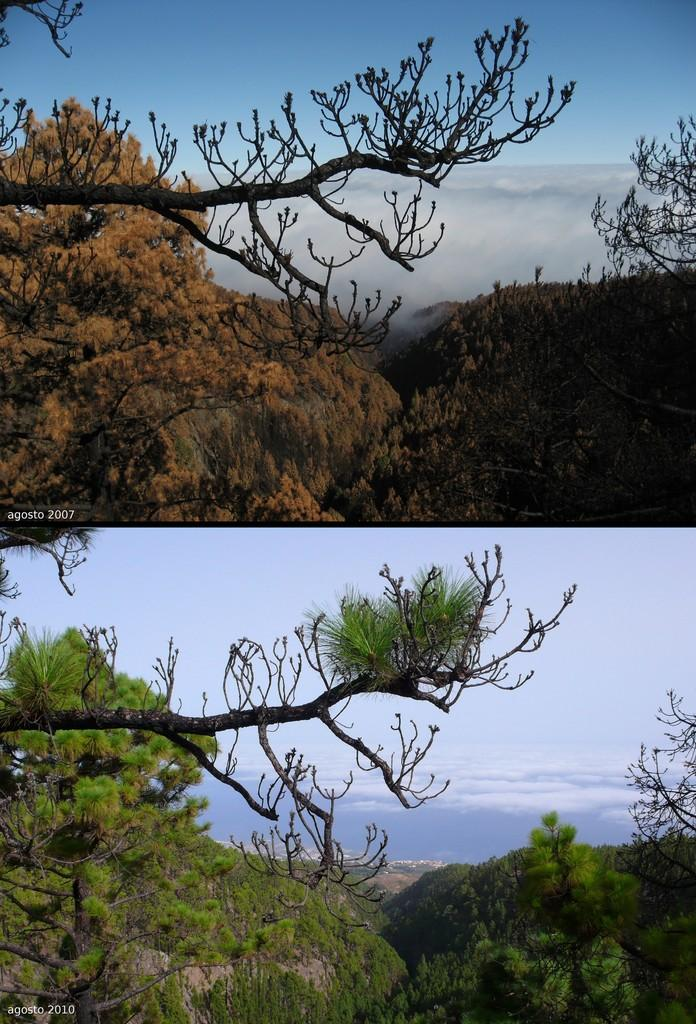What type of artwork is the image? The image is a collage. What natural elements can be seen in the collage? There are trees and clouds visible in the image. What part of the natural environment is visible in the image? The sky is visible in the image. What type of juice is being squeezed from the trees in the image? There is no juice being squeezed from the trees in the image; it is a collage featuring trees and clouds. 